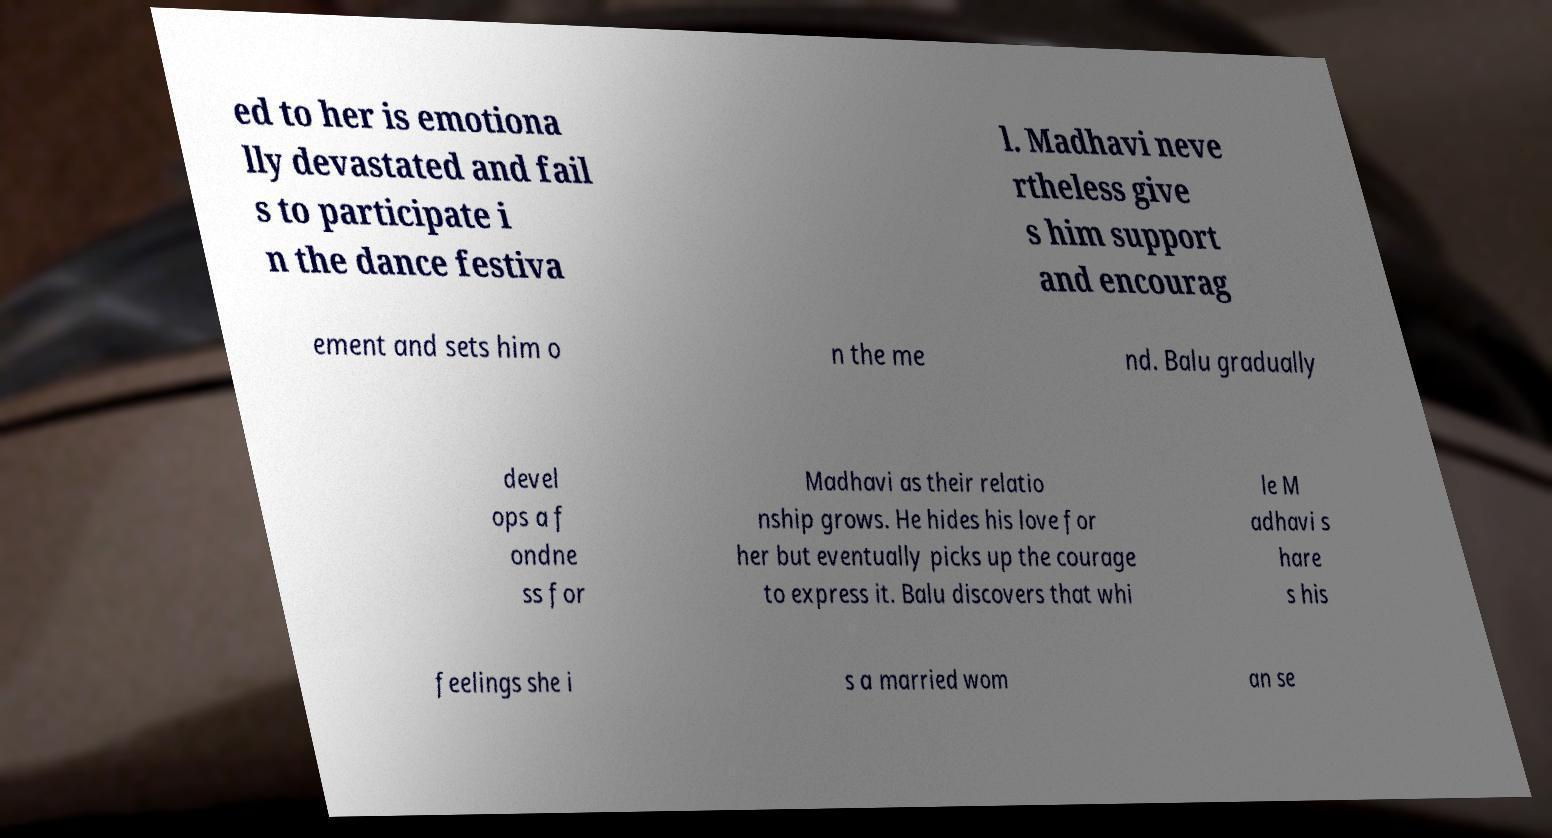For documentation purposes, I need the text within this image transcribed. Could you provide that? ed to her is emotiona lly devastated and fail s to participate i n the dance festiva l. Madhavi neve rtheless give s him support and encourag ement and sets him o n the me nd. Balu gradually devel ops a f ondne ss for Madhavi as their relatio nship grows. He hides his love for her but eventually picks up the courage to express it. Balu discovers that whi le M adhavi s hare s his feelings she i s a married wom an se 